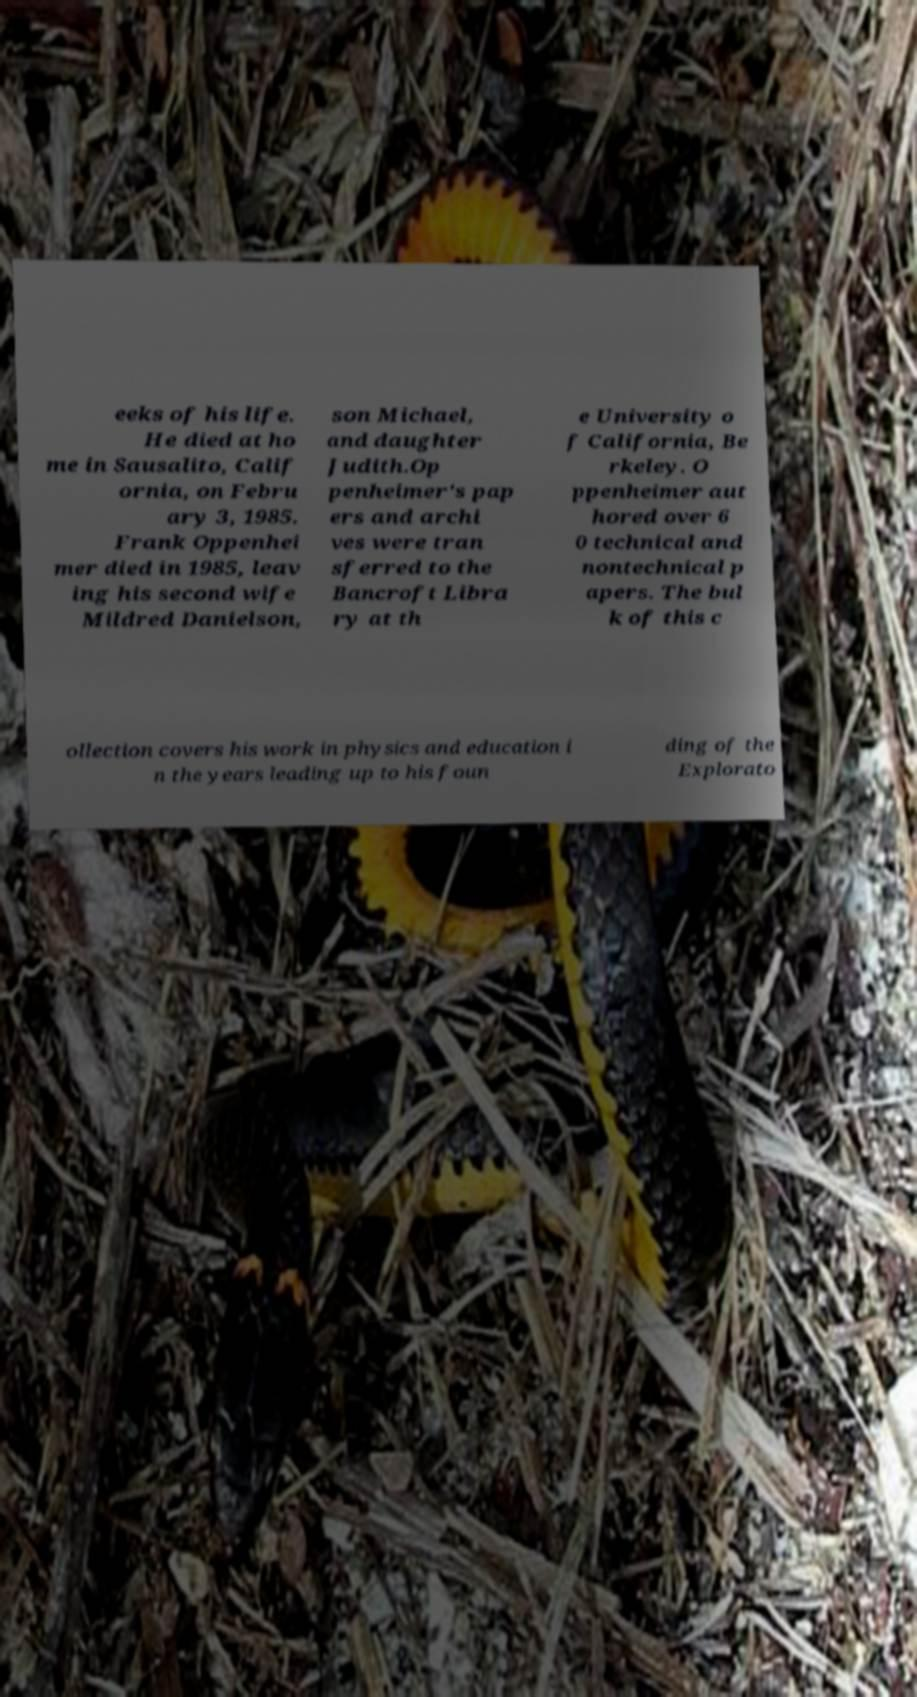Could you assist in decoding the text presented in this image and type it out clearly? eeks of his life. He died at ho me in Sausalito, Calif ornia, on Febru ary 3, 1985. Frank Oppenhei mer died in 1985, leav ing his second wife Mildred Danielson, son Michael, and daughter Judith.Op penheimer's pap ers and archi ves were tran sferred to the Bancroft Libra ry at th e University o f California, Be rkeley. O ppenheimer aut hored over 6 0 technical and nontechnical p apers. The bul k of this c ollection covers his work in physics and education i n the years leading up to his foun ding of the Explorato 